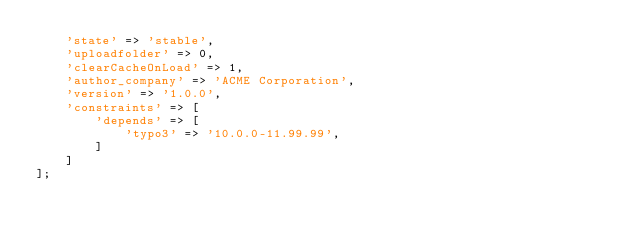<code> <loc_0><loc_0><loc_500><loc_500><_PHP_>    'state' => 'stable',
    'uploadfolder' => 0,
    'clearCacheOnLoad' => 1,
    'author_company' => 'ACME Corporation',
    'version' => '1.0.0',
    'constraints' => [
        'depends' => [
            'typo3' => '10.0.0-11.99.99',
        ]
    ]
];
</code> 